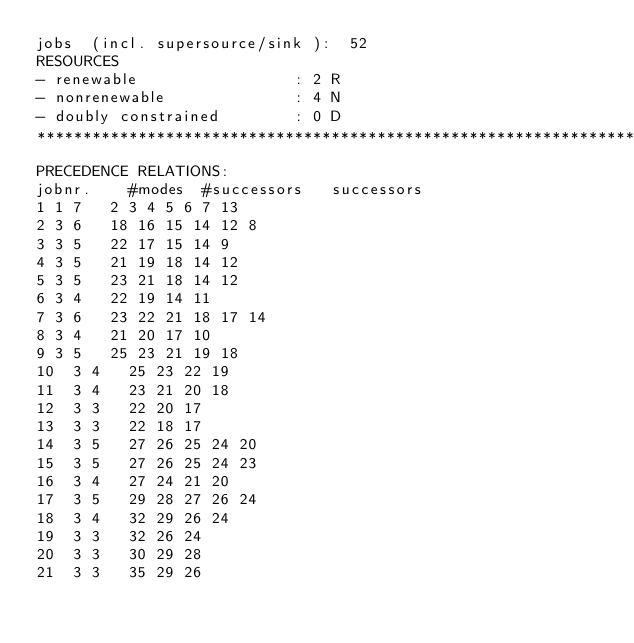<code> <loc_0><loc_0><loc_500><loc_500><_ObjectiveC_>jobs  (incl. supersource/sink ):	52
RESOURCES
- renewable                 : 2 R
- nonrenewable              : 4 N
- doubly constrained        : 0 D
************************************************************************
PRECEDENCE RELATIONS:
jobnr.    #modes  #successors   successors
1	1	7		2 3 4 5 6 7 13 
2	3	6		18 16 15 14 12 8 
3	3	5		22 17 15 14 9 
4	3	5		21 19 18 14 12 
5	3	5		23 21 18 14 12 
6	3	4		22 19 14 11 
7	3	6		23 22 21 18 17 14 
8	3	4		21 20 17 10 
9	3	5		25 23 21 19 18 
10	3	4		25 23 22 19 
11	3	4		23 21 20 18 
12	3	3		22 20 17 
13	3	3		22 18 17 
14	3	5		27 26 25 24 20 
15	3	5		27 26 25 24 23 
16	3	4		27 24 21 20 
17	3	5		29 28 27 26 24 
18	3	4		32 29 26 24 
19	3	3		32 26 24 
20	3	3		30 29 28 
21	3	3		35 29 26 </code> 